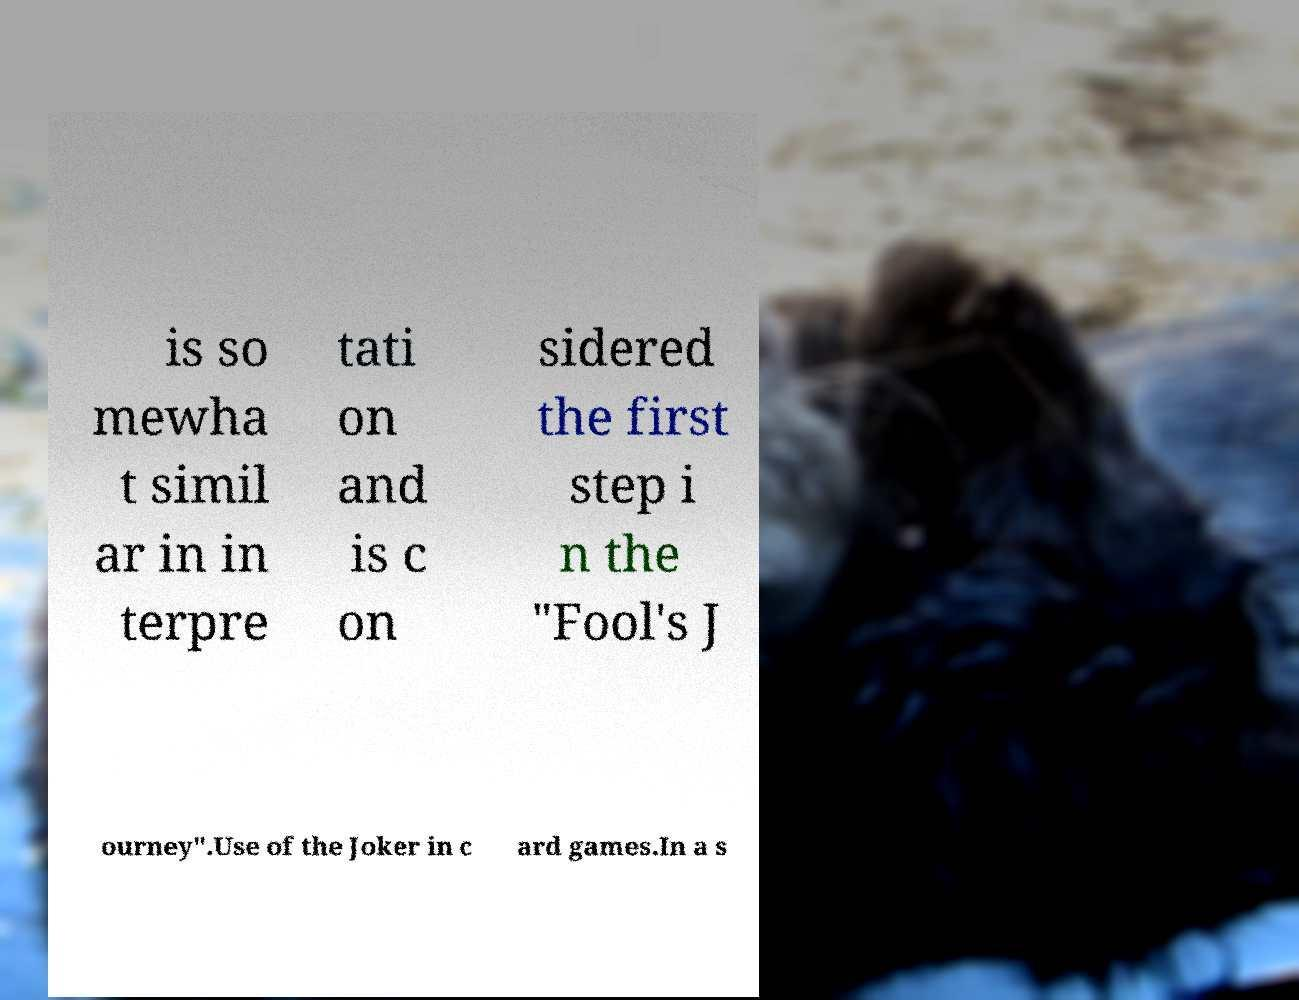What messages or text are displayed in this image? I need them in a readable, typed format. is so mewha t simil ar in in terpre tati on and is c on sidered the first step i n the "Fool's J ourney".Use of the Joker in c ard games.In a s 